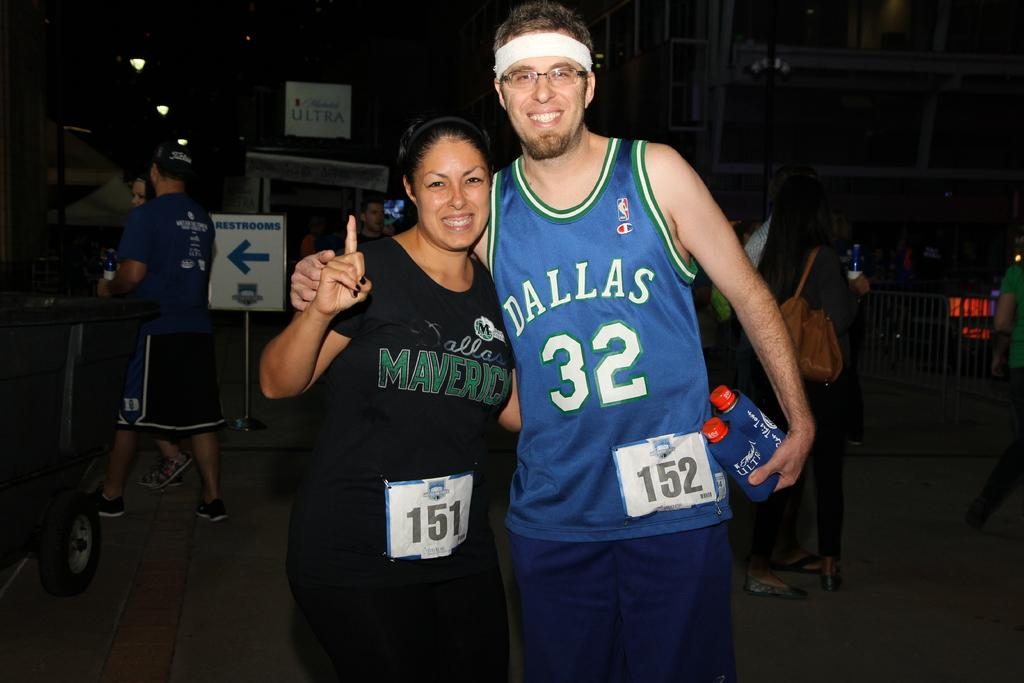Provide a one-sentence caption for the provided image. A Dallas fan is pictured with a friend holding two drinks. 